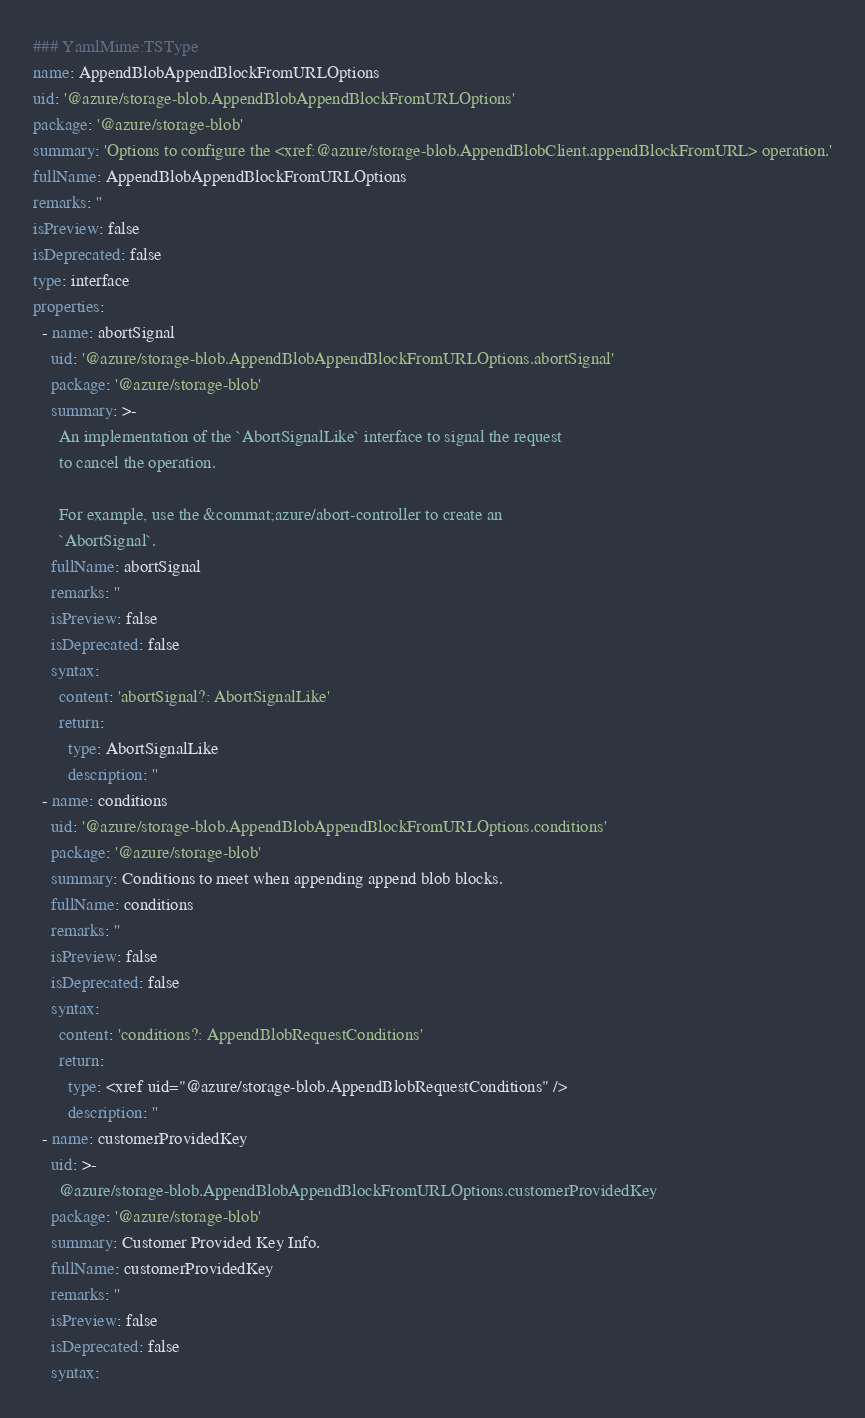<code> <loc_0><loc_0><loc_500><loc_500><_YAML_>### YamlMime:TSType
name: AppendBlobAppendBlockFromURLOptions
uid: '@azure/storage-blob.AppendBlobAppendBlockFromURLOptions'
package: '@azure/storage-blob'
summary: 'Options to configure the <xref:@azure/storage-blob.AppendBlobClient.appendBlockFromURL> operation.'
fullName: AppendBlobAppendBlockFromURLOptions
remarks: ''
isPreview: false
isDeprecated: false
type: interface
properties:
  - name: abortSignal
    uid: '@azure/storage-blob.AppendBlobAppendBlockFromURLOptions.abortSignal'
    package: '@azure/storage-blob'
    summary: >-
      An implementation of the `AbortSignalLike` interface to signal the request
      to cancel the operation.

      For example, use the &commat;azure/abort-controller to create an
      `AbortSignal`.
    fullName: abortSignal
    remarks: ''
    isPreview: false
    isDeprecated: false
    syntax:
      content: 'abortSignal?: AbortSignalLike'
      return:
        type: AbortSignalLike
        description: ''
  - name: conditions
    uid: '@azure/storage-blob.AppendBlobAppendBlockFromURLOptions.conditions'
    package: '@azure/storage-blob'
    summary: Conditions to meet when appending append blob blocks.
    fullName: conditions
    remarks: ''
    isPreview: false
    isDeprecated: false
    syntax:
      content: 'conditions?: AppendBlobRequestConditions'
      return:
        type: <xref uid="@azure/storage-blob.AppendBlobRequestConditions" />
        description: ''
  - name: customerProvidedKey
    uid: >-
      @azure/storage-blob.AppendBlobAppendBlockFromURLOptions.customerProvidedKey
    package: '@azure/storage-blob'
    summary: Customer Provided Key Info.
    fullName: customerProvidedKey
    remarks: ''
    isPreview: false
    isDeprecated: false
    syntax:</code> 